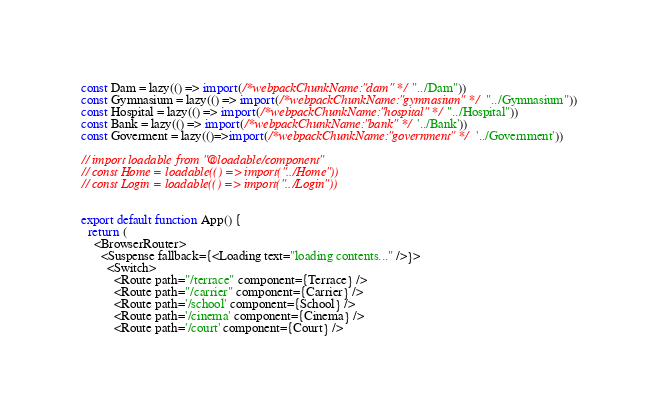<code> <loc_0><loc_0><loc_500><loc_500><_TypeScript_>const Dam = lazy(() => import(/*webpackChunkName:"dam" */"../Dam"))
const Gymnasium = lazy(() => import(/*webpackChunkName:"gymnasium" */"../Gymnasium"))
const Hospital = lazy(() => import(/*webpackChunkName:"hospital" */"../Hospital"))
const Bank = lazy(() => import(/*webpackChunkName:"bank" */'../Bank'))
const Goverment = lazy(()=>import(/*webpackChunkName:"government" */'../Government'))

// import loadable from "@loadable/component"
// const Home = loadable(() => import("../Home"))
// const Login = loadable(() => import("../Login"))


export default function App() {
  return (
    <BrowserRouter>
      <Suspense fallback={<Loading text="loading contents..." />}>
        <Switch>
          <Route path="/terrace" component={Terrace} />
          <Route path="/carrier" component={Carrier} />
          <Route path='/school' component={School} />
          <Route path='/cinema' component={Cinema} />
          <Route path='/court' component={Court} /></code> 